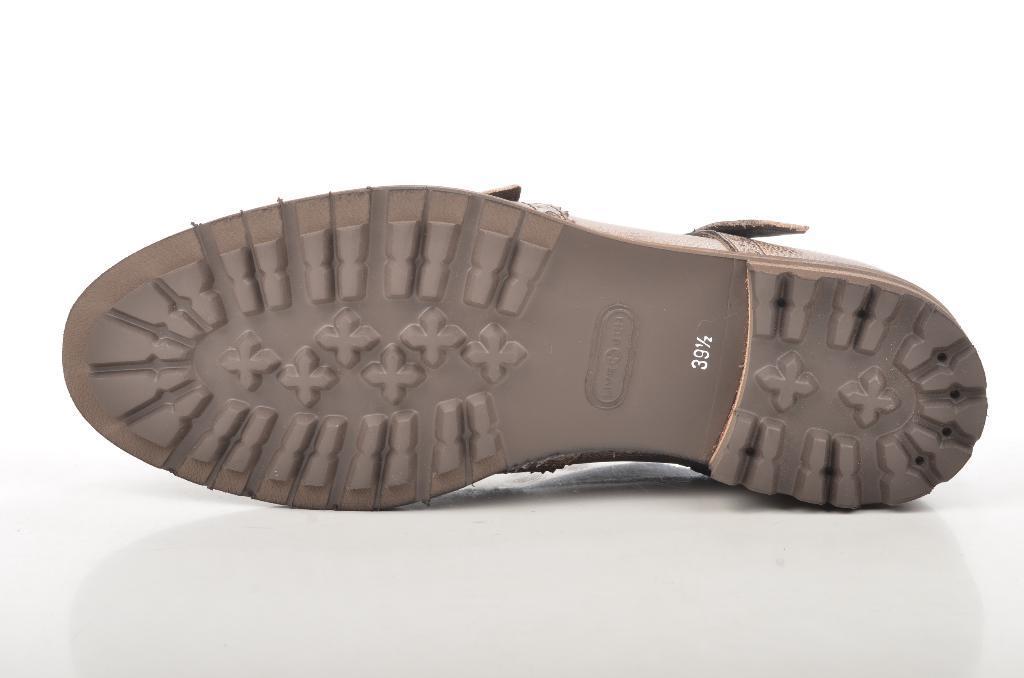Describe this image in one or two sentences. In the picture I can see footwear on a white color surface. The background of the image is white in color. 